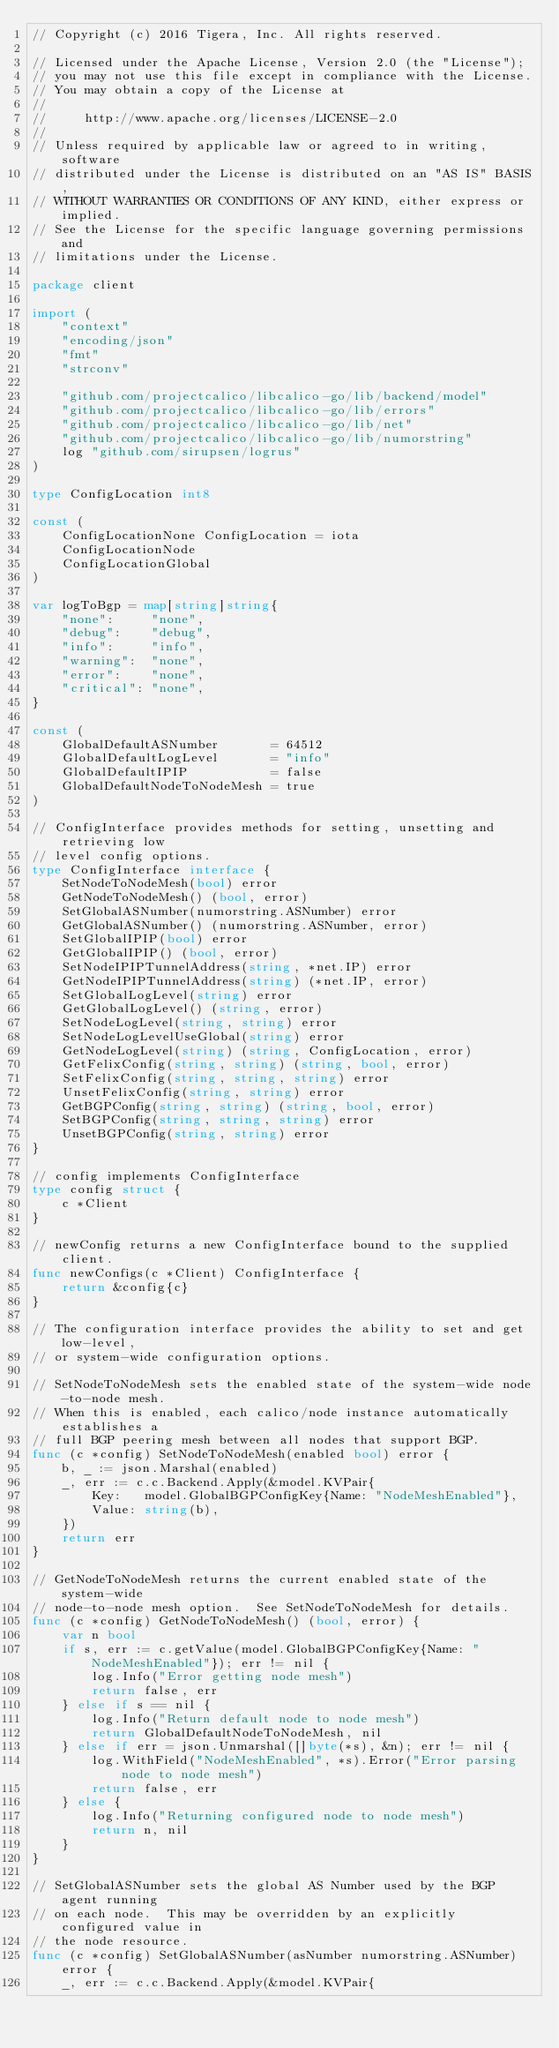Convert code to text. <code><loc_0><loc_0><loc_500><loc_500><_Go_>// Copyright (c) 2016 Tigera, Inc. All rights reserved.

// Licensed under the Apache License, Version 2.0 (the "License");
// you may not use this file except in compliance with the License.
// You may obtain a copy of the License at
//
//     http://www.apache.org/licenses/LICENSE-2.0
//
// Unless required by applicable law or agreed to in writing, software
// distributed under the License is distributed on an "AS IS" BASIS,
// WITHOUT WARRANTIES OR CONDITIONS OF ANY KIND, either express or implied.
// See the License for the specific language governing permissions and
// limitations under the License.

package client

import (
	"context"
	"encoding/json"
	"fmt"
	"strconv"

	"github.com/projectcalico/libcalico-go/lib/backend/model"
	"github.com/projectcalico/libcalico-go/lib/errors"
	"github.com/projectcalico/libcalico-go/lib/net"
	"github.com/projectcalico/libcalico-go/lib/numorstring"
	log "github.com/sirupsen/logrus"
)

type ConfigLocation int8

const (
	ConfigLocationNone ConfigLocation = iota
	ConfigLocationNode
	ConfigLocationGlobal
)

var logToBgp = map[string]string{
	"none":     "none",
	"debug":    "debug",
	"info":     "info",
	"warning":  "none",
	"error":    "none",
	"critical": "none",
}

const (
	GlobalDefaultASNumber       = 64512
	GlobalDefaultLogLevel       = "info"
	GlobalDefaultIPIP           = false
	GlobalDefaultNodeToNodeMesh = true
)

// ConfigInterface provides methods for setting, unsetting and retrieving low
// level config options.
type ConfigInterface interface {
	SetNodeToNodeMesh(bool) error
	GetNodeToNodeMesh() (bool, error)
	SetGlobalASNumber(numorstring.ASNumber) error
	GetGlobalASNumber() (numorstring.ASNumber, error)
	SetGlobalIPIP(bool) error
	GetGlobalIPIP() (bool, error)
	SetNodeIPIPTunnelAddress(string, *net.IP) error
	GetNodeIPIPTunnelAddress(string) (*net.IP, error)
	SetGlobalLogLevel(string) error
	GetGlobalLogLevel() (string, error)
	SetNodeLogLevel(string, string) error
	SetNodeLogLevelUseGlobal(string) error
	GetNodeLogLevel(string) (string, ConfigLocation, error)
	GetFelixConfig(string, string) (string, bool, error)
	SetFelixConfig(string, string, string) error
	UnsetFelixConfig(string, string) error
	GetBGPConfig(string, string) (string, bool, error)
	SetBGPConfig(string, string, string) error
	UnsetBGPConfig(string, string) error
}

// config implements ConfigInterface
type config struct {
	c *Client
}

// newConfig returns a new ConfigInterface bound to the supplied client.
func newConfigs(c *Client) ConfigInterface {
	return &config{c}
}

// The configuration interface provides the ability to set and get low-level,
// or system-wide configuration options.

// SetNodeToNodeMesh sets the enabled state of the system-wide node-to-node mesh.
// When this is enabled, each calico/node instance automatically establishes a
// full BGP peering mesh between all nodes that support BGP.
func (c *config) SetNodeToNodeMesh(enabled bool) error {
	b, _ := json.Marshal(enabled)
	_, err := c.c.Backend.Apply(&model.KVPair{
		Key:   model.GlobalBGPConfigKey{Name: "NodeMeshEnabled"},
		Value: string(b),
	})
	return err
}

// GetNodeToNodeMesh returns the current enabled state of the system-wide
// node-to-node mesh option.  See SetNodeToNodeMesh for details.
func (c *config) GetNodeToNodeMesh() (bool, error) {
	var n bool
	if s, err := c.getValue(model.GlobalBGPConfigKey{Name: "NodeMeshEnabled"}); err != nil {
		log.Info("Error getting node mesh")
		return false, err
	} else if s == nil {
		log.Info("Return default node to node mesh")
		return GlobalDefaultNodeToNodeMesh, nil
	} else if err = json.Unmarshal([]byte(*s), &n); err != nil {
		log.WithField("NodeMeshEnabled", *s).Error("Error parsing node to node mesh")
		return false, err
	} else {
		log.Info("Returning configured node to node mesh")
		return n, nil
	}
}

// SetGlobalASNumber sets the global AS Number used by the BGP agent running
// on each node.  This may be overridden by an explicitly configured value in
// the node resource.
func (c *config) SetGlobalASNumber(asNumber numorstring.ASNumber) error {
	_, err := c.c.Backend.Apply(&model.KVPair{</code> 